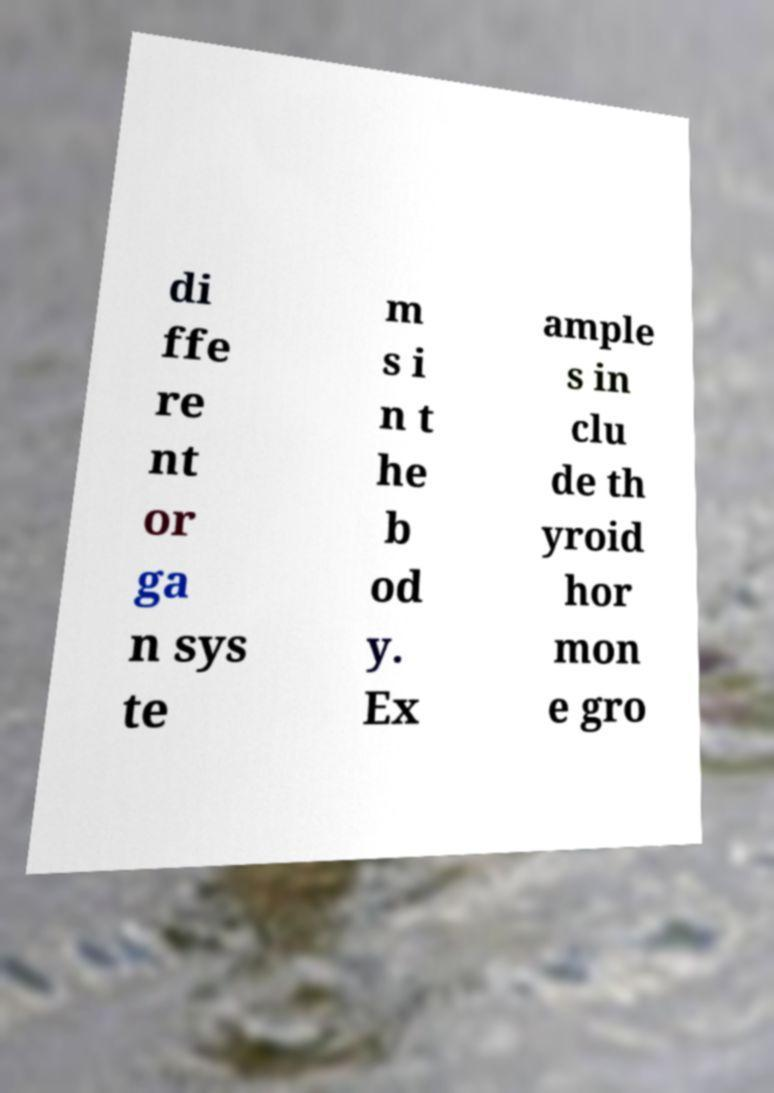Could you assist in decoding the text presented in this image and type it out clearly? di ffe re nt or ga n sys te m s i n t he b od y. Ex ample s in clu de th yroid hor mon e gro 